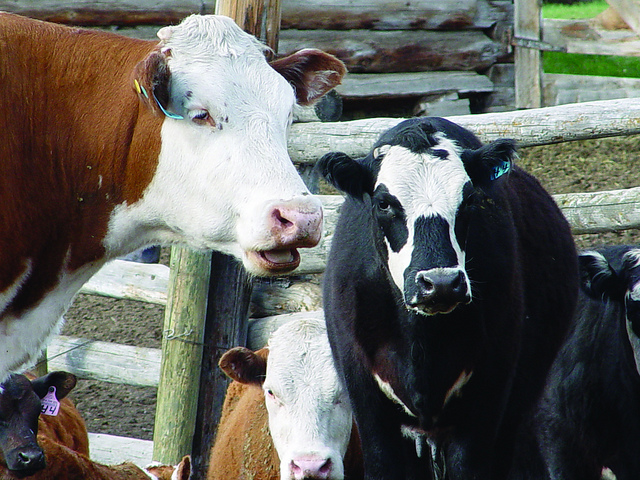How do farmers ensure the welfare of their cattle? Farmers ensure the welfare of their cattle by providing proper nutrition, clean water, safe housing, regular health check-ups, and vaccinations. They also follow guidelines for ethical treatment, which includes taking steps to minimize stress and discomfort for the animals. Good welfare practices lead to healthier animals and higher quality produce. 